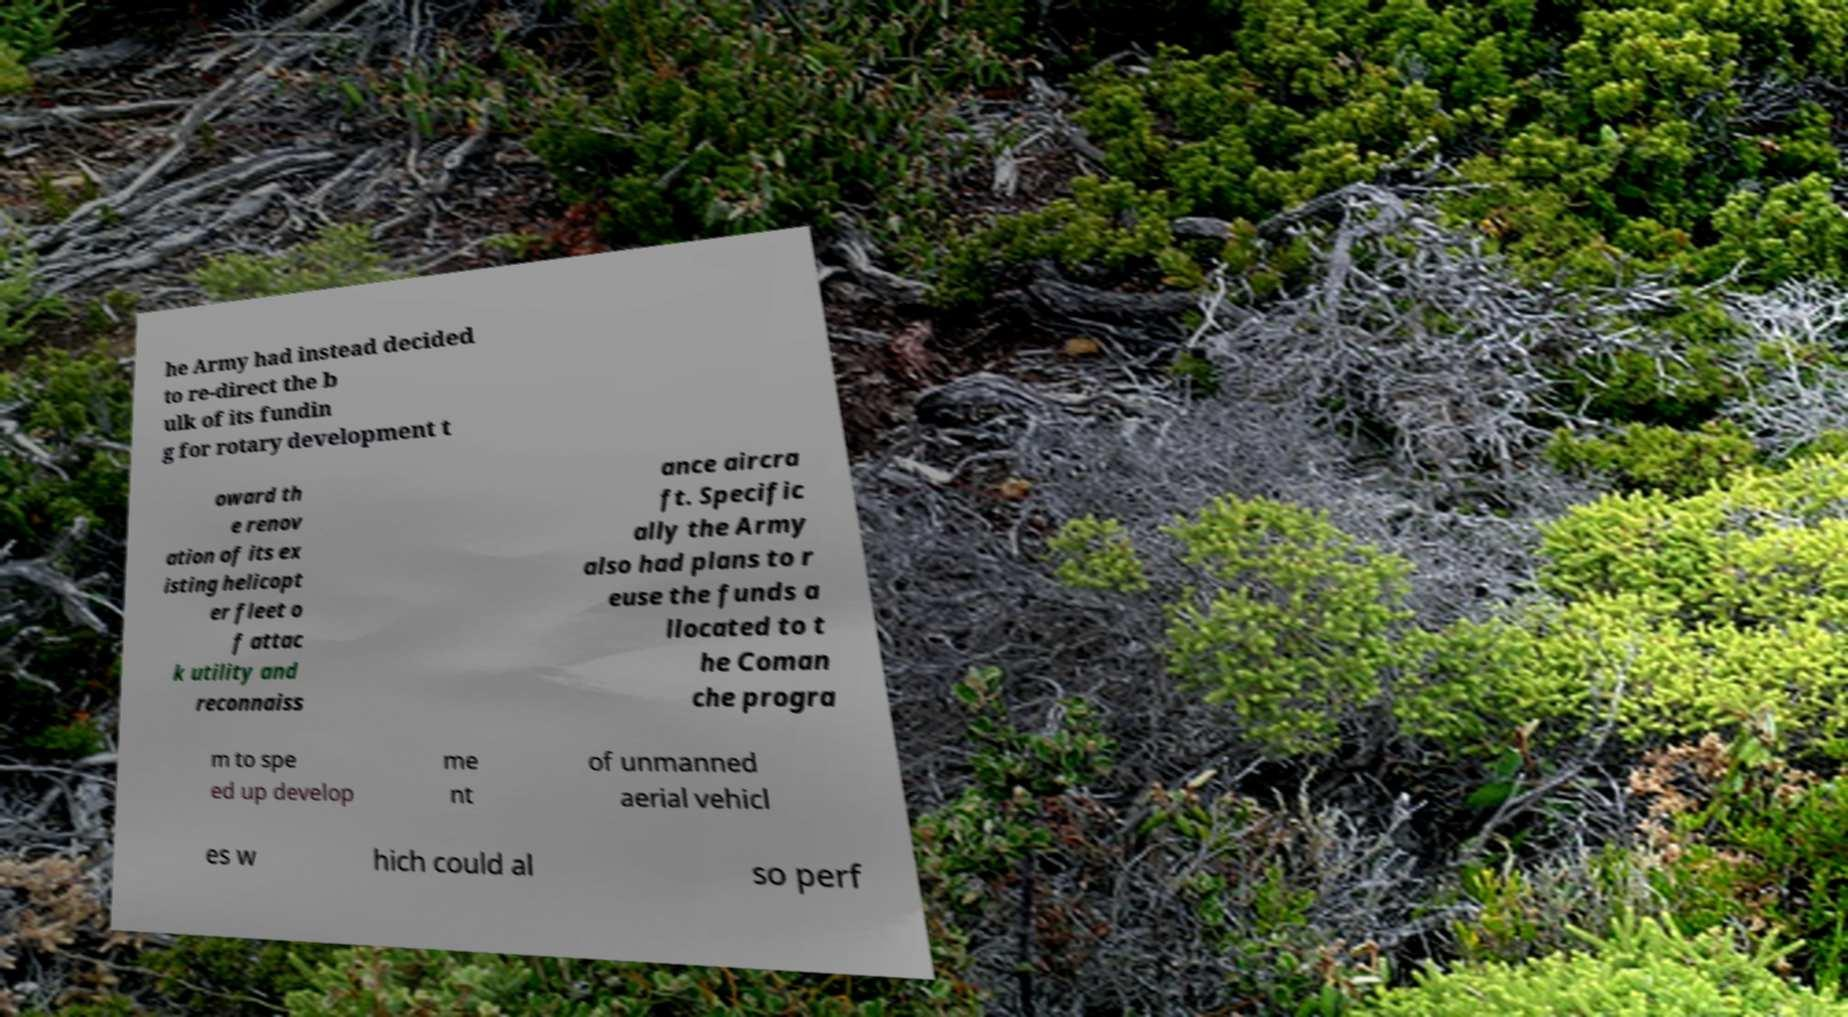For documentation purposes, I need the text within this image transcribed. Could you provide that? he Army had instead decided to re-direct the b ulk of its fundin g for rotary development t oward th e renov ation of its ex isting helicopt er fleet o f attac k utility and reconnaiss ance aircra ft. Specific ally the Army also had plans to r euse the funds a llocated to t he Coman che progra m to spe ed up develop me nt of unmanned aerial vehicl es w hich could al so perf 